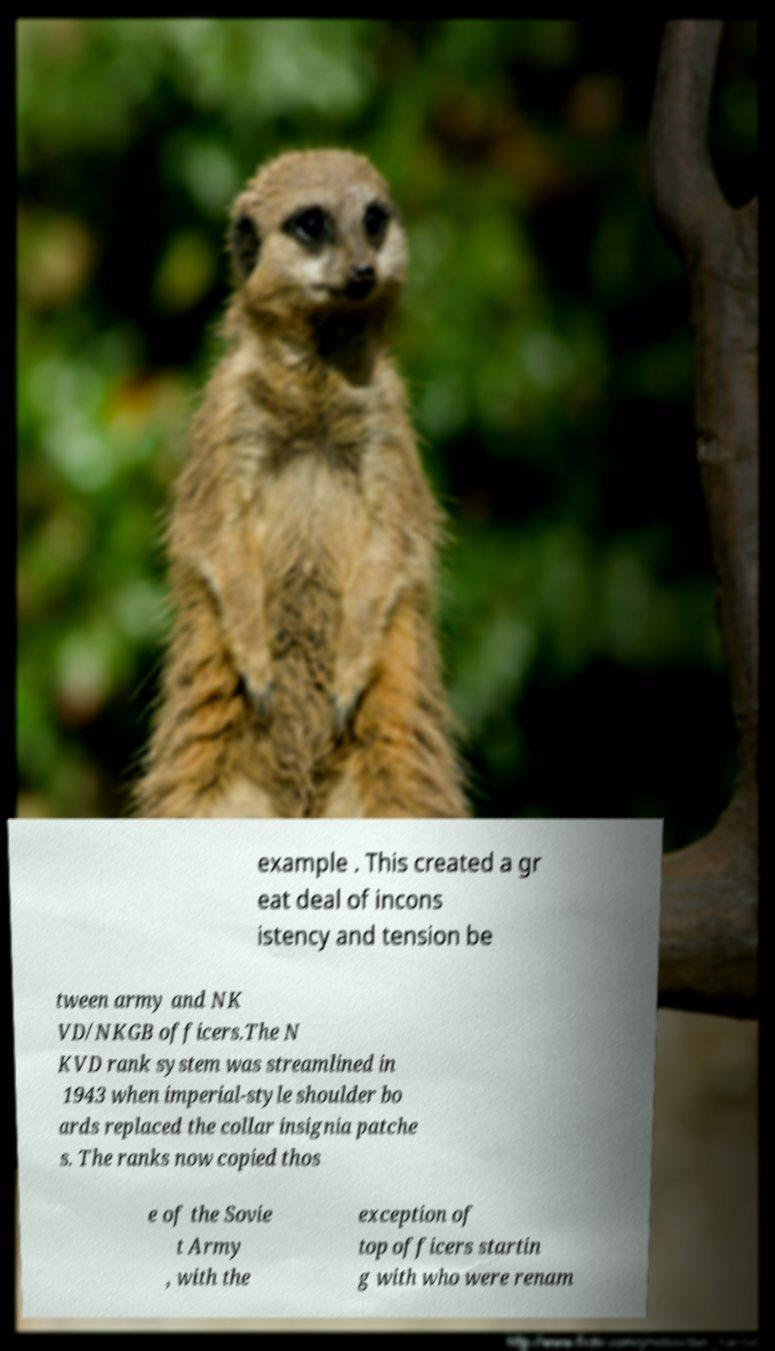Could you assist in decoding the text presented in this image and type it out clearly? example . This created a gr eat deal of incons istency and tension be tween army and NK VD/NKGB officers.The N KVD rank system was streamlined in 1943 when imperial-style shoulder bo ards replaced the collar insignia patche s. The ranks now copied thos e of the Sovie t Army , with the exception of top officers startin g with who were renam 